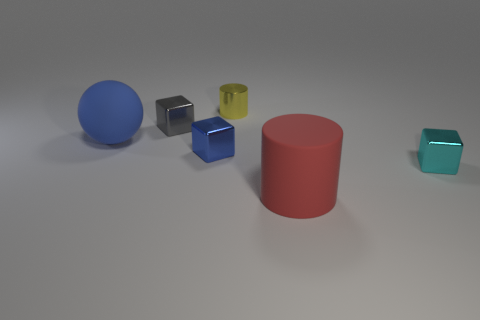Subtract all tiny blue metal cubes. How many cubes are left? 2 Subtract all cyan cubes. How many cubes are left? 2 Subtract all spheres. How many objects are left? 5 Add 2 tiny purple rubber things. How many objects exist? 8 Subtract 0 green spheres. How many objects are left? 6 Subtract 1 balls. How many balls are left? 0 Subtract all cyan balls. Subtract all gray cubes. How many balls are left? 1 Subtract all yellow balls. How many red cylinders are left? 1 Subtract all blue matte cylinders. Subtract all big red rubber objects. How many objects are left? 5 Add 4 big rubber cylinders. How many big rubber cylinders are left? 5 